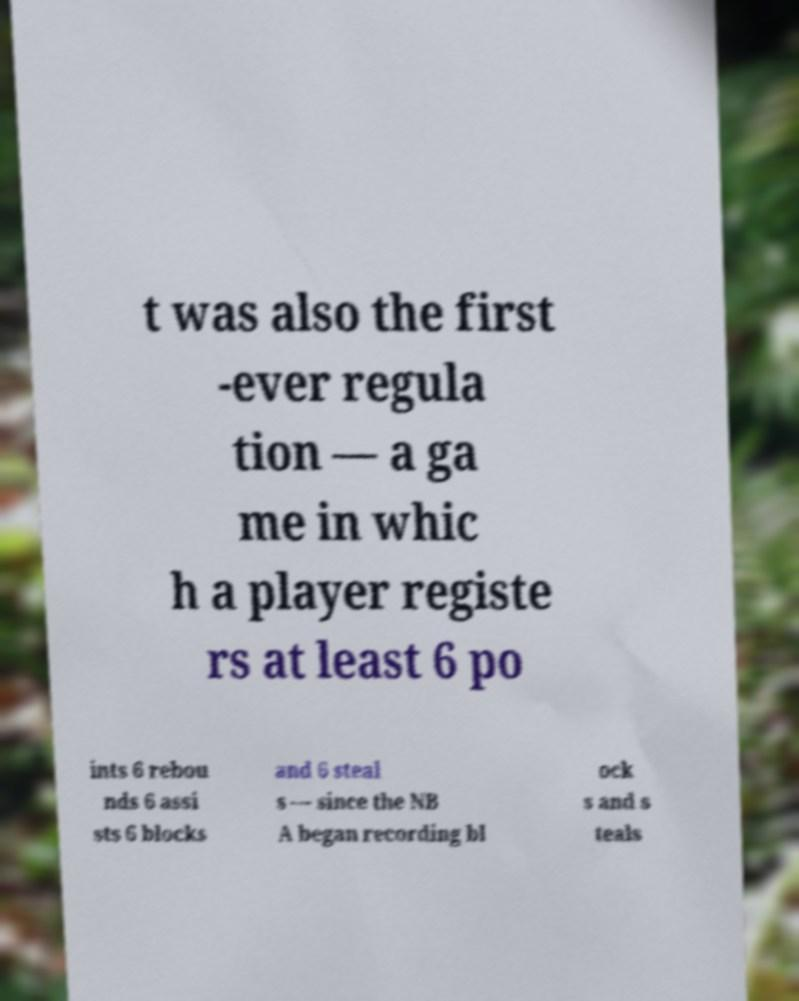There's text embedded in this image that I need extracted. Can you transcribe it verbatim? t was also the first -ever regula tion — a ga me in whic h a player registe rs at least 6 po ints 6 rebou nds 6 assi sts 6 blocks and 6 steal s — since the NB A began recording bl ock s and s teals 